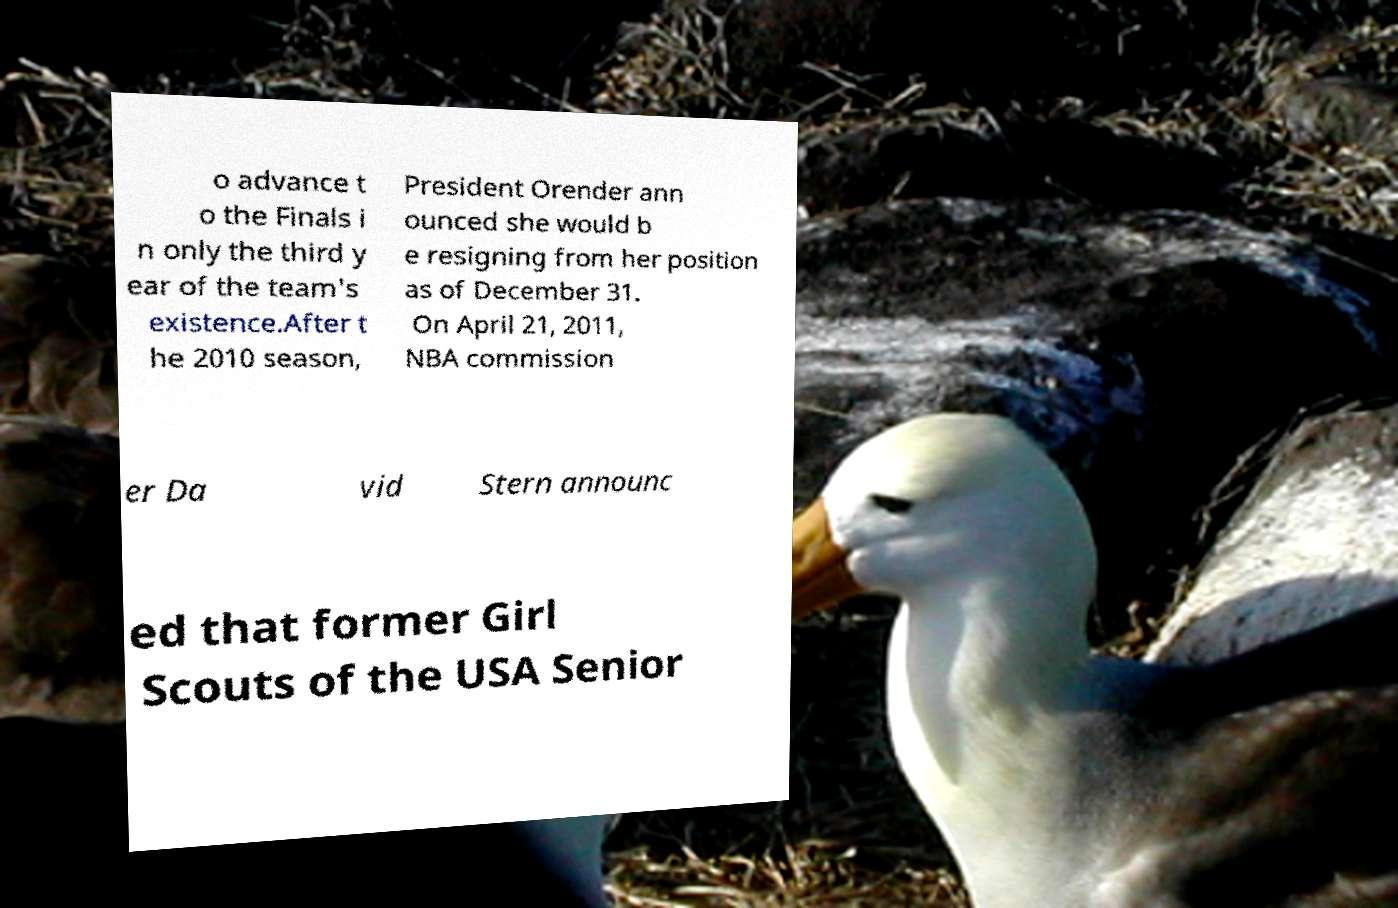There's text embedded in this image that I need extracted. Can you transcribe it verbatim? o advance t o the Finals i n only the third y ear of the team's existence.After t he 2010 season, President Orender ann ounced she would b e resigning from her position as of December 31. On April 21, 2011, NBA commission er Da vid Stern announc ed that former Girl Scouts of the USA Senior 